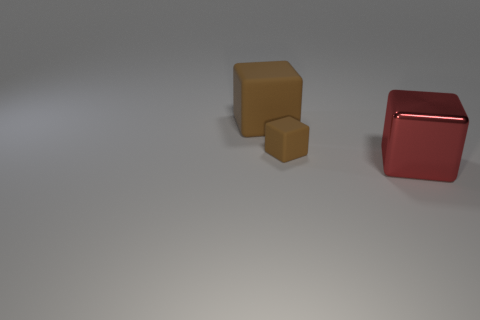Are there any other things that are the same color as the metallic block?
Keep it short and to the point. No. There is a block that is both behind the large red block and to the right of the large brown rubber cube; how big is it?
Provide a short and direct response. Small. There is a matte thing that is the same color as the tiny rubber cube; what shape is it?
Provide a succinct answer. Cube. What color is the small matte block?
Give a very brief answer. Brown. What is the shape of the thing that is the same size as the red metal block?
Keep it short and to the point. Cube. The large thing that is behind the brown thing that is right of the large block behind the metallic block is what shape?
Provide a short and direct response. Cube. Is the large brown cube made of the same material as the large block to the right of the small object?
Ensure brevity in your answer.  No. There is another brown rubber thing that is the same shape as the big brown rubber object; what is its size?
Make the answer very short. Small. Are there an equal number of brown objects that are in front of the red object and big red things to the left of the large matte thing?
Your answer should be very brief. Yes. Are there an equal number of big metal objects left of the red block and large metal things?
Keep it short and to the point. No. 